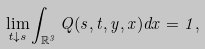<formula> <loc_0><loc_0><loc_500><loc_500>\lim _ { t \downarrow s } \int _ { \mathbb { R } ^ { 3 } } Q ( s , t , y , x ) d x = 1 ,</formula> 